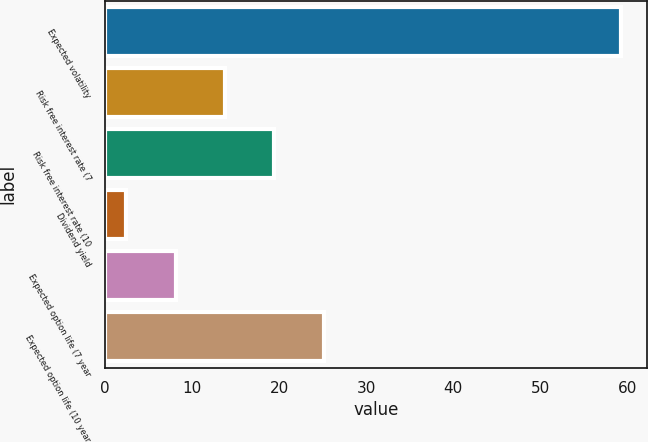<chart> <loc_0><loc_0><loc_500><loc_500><bar_chart><fcel>Expected volatility<fcel>Risk free interest rate (7<fcel>Risk free interest rate (10<fcel>Dividend yield<fcel>Expected option life (7 year<fcel>Expected option life (10 year<nl><fcel>59.27<fcel>13.77<fcel>19.46<fcel>2.39<fcel>8.08<fcel>25.15<nl></chart> 